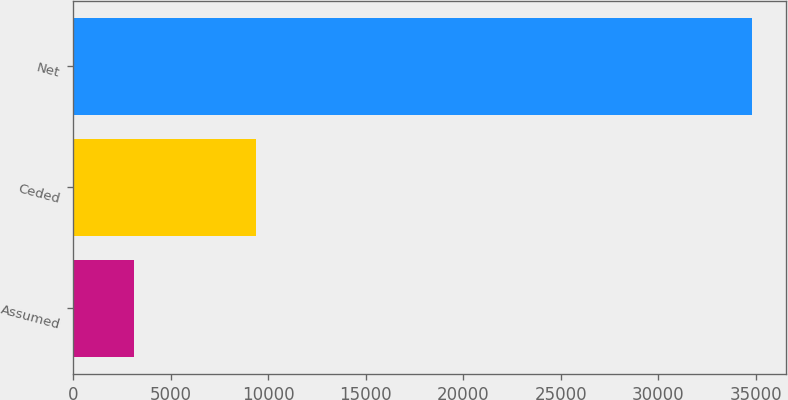<chart> <loc_0><loc_0><loc_500><loc_500><bar_chart><fcel>Assumed<fcel>Ceded<fcel>Net<nl><fcel>3133<fcel>9375<fcel>34786<nl></chart> 